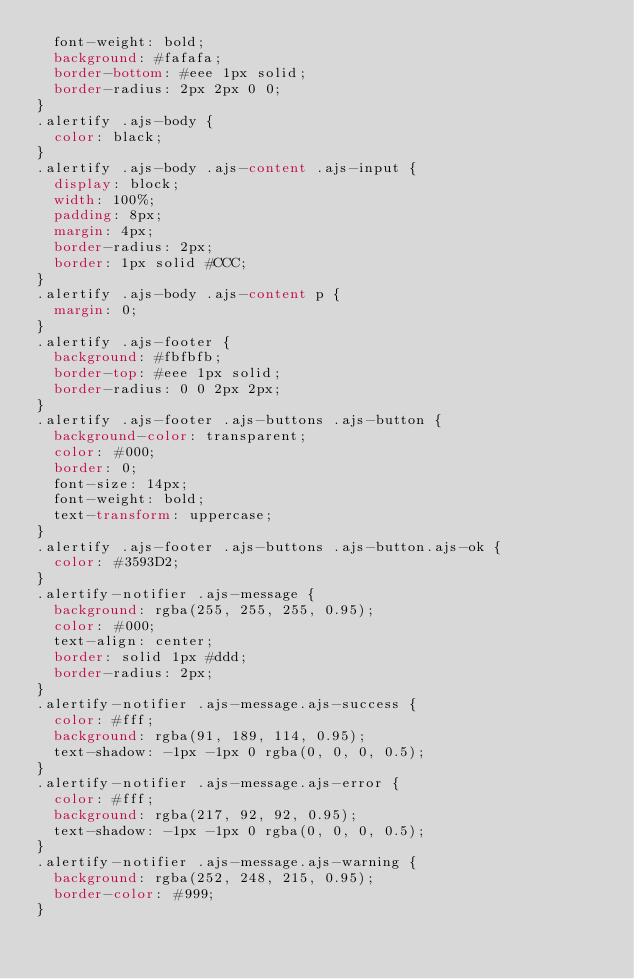Convert code to text. <code><loc_0><loc_0><loc_500><loc_500><_CSS_>  font-weight: bold;
  background: #fafafa;
  border-bottom: #eee 1px solid;
  border-radius: 2px 2px 0 0;
}
.alertify .ajs-body {
  color: black;
}
.alertify .ajs-body .ajs-content .ajs-input {
  display: block;
  width: 100%;
  padding: 8px;
  margin: 4px;
  border-radius: 2px;
  border: 1px solid #CCC;
}
.alertify .ajs-body .ajs-content p {
  margin: 0;
}
.alertify .ajs-footer {
  background: #fbfbfb;
  border-top: #eee 1px solid;
  border-radius: 0 0 2px 2px;
}
.alertify .ajs-footer .ajs-buttons .ajs-button {
  background-color: transparent;
  color: #000;
  border: 0;
  font-size: 14px;
  font-weight: bold;
  text-transform: uppercase;
}
.alertify .ajs-footer .ajs-buttons .ajs-button.ajs-ok {
  color: #3593D2;
}
.alertify-notifier .ajs-message {
  background: rgba(255, 255, 255, 0.95);
  color: #000;
  text-align: center;
  border: solid 1px #ddd;
  border-radius: 2px;
}
.alertify-notifier .ajs-message.ajs-success {
  color: #fff;
  background: rgba(91, 189, 114, 0.95);
  text-shadow: -1px -1px 0 rgba(0, 0, 0, 0.5);
}
.alertify-notifier .ajs-message.ajs-error {
  color: #fff;
  background: rgba(217, 92, 92, 0.95);
  text-shadow: -1px -1px 0 rgba(0, 0, 0, 0.5);
}
.alertify-notifier .ajs-message.ajs-warning {
  background: rgba(252, 248, 215, 0.95);
  border-color: #999;
}
</code> 